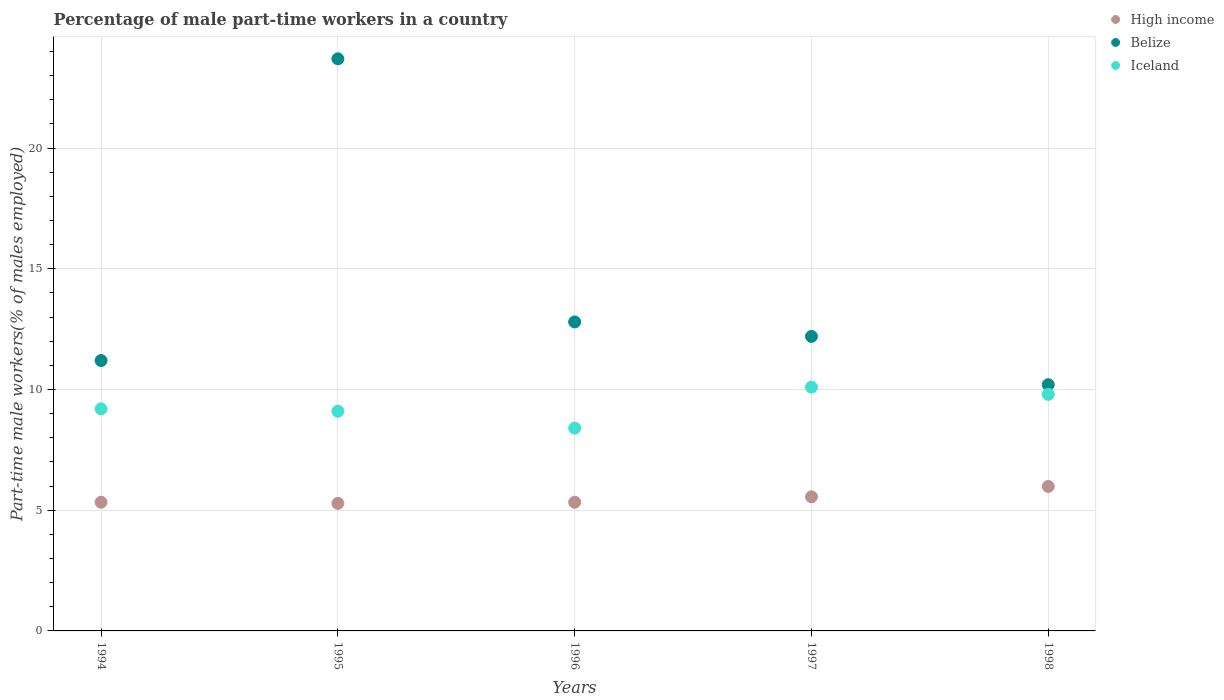What is the percentage of male part-time workers in Belize in 1994?
Keep it short and to the point. 11.2. Across all years, what is the maximum percentage of male part-time workers in Belize?
Provide a short and direct response. 23.7. Across all years, what is the minimum percentage of male part-time workers in High income?
Keep it short and to the point. 5.28. In which year was the percentage of male part-time workers in Iceland maximum?
Offer a very short reply. 1997. In which year was the percentage of male part-time workers in Belize minimum?
Ensure brevity in your answer.  1998. What is the total percentage of male part-time workers in Belize in the graph?
Make the answer very short. 70.1. What is the difference between the percentage of male part-time workers in Iceland in 1997 and that in 1998?
Keep it short and to the point. 0.3. What is the difference between the percentage of male part-time workers in High income in 1998 and the percentage of male part-time workers in Iceland in 1994?
Offer a very short reply. -3.22. What is the average percentage of male part-time workers in Iceland per year?
Offer a very short reply. 9.32. In the year 1996, what is the difference between the percentage of male part-time workers in Iceland and percentage of male part-time workers in High income?
Offer a terse response. 3.07. In how many years, is the percentage of male part-time workers in Belize greater than 21 %?
Offer a terse response. 1. What is the ratio of the percentage of male part-time workers in Belize in 1997 to that in 1998?
Offer a very short reply. 1.2. Is the percentage of male part-time workers in Iceland in 1994 less than that in 1996?
Give a very brief answer. No. What is the difference between the highest and the second highest percentage of male part-time workers in Belize?
Provide a succinct answer. 10.9. What is the difference between the highest and the lowest percentage of male part-time workers in Iceland?
Offer a terse response. 1.7. In how many years, is the percentage of male part-time workers in High income greater than the average percentage of male part-time workers in High income taken over all years?
Keep it short and to the point. 2. Is the sum of the percentage of male part-time workers in High income in 1994 and 1995 greater than the maximum percentage of male part-time workers in Belize across all years?
Provide a succinct answer. No. How many dotlines are there?
Make the answer very short. 3. How many years are there in the graph?
Offer a very short reply. 5. Does the graph contain grids?
Provide a short and direct response. Yes. Where does the legend appear in the graph?
Ensure brevity in your answer.  Top right. How many legend labels are there?
Offer a very short reply. 3. How are the legend labels stacked?
Make the answer very short. Vertical. What is the title of the graph?
Your response must be concise. Percentage of male part-time workers in a country. What is the label or title of the Y-axis?
Provide a short and direct response. Part-time male workers(% of males employed). What is the Part-time male workers(% of males employed) of High income in 1994?
Offer a terse response. 5.33. What is the Part-time male workers(% of males employed) in Belize in 1994?
Offer a terse response. 11.2. What is the Part-time male workers(% of males employed) of Iceland in 1994?
Ensure brevity in your answer.  9.2. What is the Part-time male workers(% of males employed) of High income in 1995?
Your answer should be compact. 5.28. What is the Part-time male workers(% of males employed) in Belize in 1995?
Keep it short and to the point. 23.7. What is the Part-time male workers(% of males employed) of Iceland in 1995?
Your answer should be compact. 9.1. What is the Part-time male workers(% of males employed) in High income in 1996?
Provide a succinct answer. 5.33. What is the Part-time male workers(% of males employed) in Belize in 1996?
Your response must be concise. 12.8. What is the Part-time male workers(% of males employed) of Iceland in 1996?
Your response must be concise. 8.4. What is the Part-time male workers(% of males employed) of High income in 1997?
Offer a very short reply. 5.56. What is the Part-time male workers(% of males employed) of Belize in 1997?
Your answer should be very brief. 12.2. What is the Part-time male workers(% of males employed) in Iceland in 1997?
Provide a succinct answer. 10.1. What is the Part-time male workers(% of males employed) of High income in 1998?
Provide a succinct answer. 5.98. What is the Part-time male workers(% of males employed) in Belize in 1998?
Your answer should be very brief. 10.2. What is the Part-time male workers(% of males employed) of Iceland in 1998?
Your response must be concise. 9.8. Across all years, what is the maximum Part-time male workers(% of males employed) of High income?
Give a very brief answer. 5.98. Across all years, what is the maximum Part-time male workers(% of males employed) in Belize?
Provide a short and direct response. 23.7. Across all years, what is the maximum Part-time male workers(% of males employed) in Iceland?
Your answer should be compact. 10.1. Across all years, what is the minimum Part-time male workers(% of males employed) of High income?
Ensure brevity in your answer.  5.28. Across all years, what is the minimum Part-time male workers(% of males employed) in Belize?
Your answer should be very brief. 10.2. Across all years, what is the minimum Part-time male workers(% of males employed) in Iceland?
Provide a short and direct response. 8.4. What is the total Part-time male workers(% of males employed) of High income in the graph?
Offer a very short reply. 27.49. What is the total Part-time male workers(% of males employed) of Belize in the graph?
Make the answer very short. 70.1. What is the total Part-time male workers(% of males employed) of Iceland in the graph?
Provide a short and direct response. 46.6. What is the difference between the Part-time male workers(% of males employed) of High income in 1994 and that in 1995?
Ensure brevity in your answer.  0.05. What is the difference between the Part-time male workers(% of males employed) in High income in 1994 and that in 1996?
Ensure brevity in your answer.  0. What is the difference between the Part-time male workers(% of males employed) of Belize in 1994 and that in 1996?
Your response must be concise. -1.6. What is the difference between the Part-time male workers(% of males employed) of Iceland in 1994 and that in 1996?
Keep it short and to the point. 0.8. What is the difference between the Part-time male workers(% of males employed) of High income in 1994 and that in 1997?
Your response must be concise. -0.22. What is the difference between the Part-time male workers(% of males employed) of Iceland in 1994 and that in 1997?
Your answer should be very brief. -0.9. What is the difference between the Part-time male workers(% of males employed) of High income in 1994 and that in 1998?
Offer a terse response. -0.65. What is the difference between the Part-time male workers(% of males employed) in Belize in 1994 and that in 1998?
Ensure brevity in your answer.  1. What is the difference between the Part-time male workers(% of males employed) of High income in 1995 and that in 1996?
Provide a succinct answer. -0.05. What is the difference between the Part-time male workers(% of males employed) of Belize in 1995 and that in 1996?
Provide a succinct answer. 10.9. What is the difference between the Part-time male workers(% of males employed) in Iceland in 1995 and that in 1996?
Offer a very short reply. 0.7. What is the difference between the Part-time male workers(% of males employed) in High income in 1995 and that in 1997?
Offer a terse response. -0.27. What is the difference between the Part-time male workers(% of males employed) in Belize in 1995 and that in 1997?
Your response must be concise. 11.5. What is the difference between the Part-time male workers(% of males employed) in High income in 1995 and that in 1998?
Keep it short and to the point. -0.7. What is the difference between the Part-time male workers(% of males employed) in High income in 1996 and that in 1997?
Offer a very short reply. -0.22. What is the difference between the Part-time male workers(% of males employed) of Belize in 1996 and that in 1997?
Offer a terse response. 0.6. What is the difference between the Part-time male workers(% of males employed) in Iceland in 1996 and that in 1997?
Give a very brief answer. -1.7. What is the difference between the Part-time male workers(% of males employed) of High income in 1996 and that in 1998?
Give a very brief answer. -0.65. What is the difference between the Part-time male workers(% of males employed) in High income in 1997 and that in 1998?
Your answer should be compact. -0.43. What is the difference between the Part-time male workers(% of males employed) in Belize in 1997 and that in 1998?
Your answer should be compact. 2. What is the difference between the Part-time male workers(% of males employed) of Iceland in 1997 and that in 1998?
Your answer should be compact. 0.3. What is the difference between the Part-time male workers(% of males employed) in High income in 1994 and the Part-time male workers(% of males employed) in Belize in 1995?
Keep it short and to the point. -18.37. What is the difference between the Part-time male workers(% of males employed) of High income in 1994 and the Part-time male workers(% of males employed) of Iceland in 1995?
Offer a terse response. -3.77. What is the difference between the Part-time male workers(% of males employed) in Belize in 1994 and the Part-time male workers(% of males employed) in Iceland in 1995?
Ensure brevity in your answer.  2.1. What is the difference between the Part-time male workers(% of males employed) in High income in 1994 and the Part-time male workers(% of males employed) in Belize in 1996?
Your answer should be very brief. -7.47. What is the difference between the Part-time male workers(% of males employed) of High income in 1994 and the Part-time male workers(% of males employed) of Iceland in 1996?
Offer a terse response. -3.07. What is the difference between the Part-time male workers(% of males employed) in High income in 1994 and the Part-time male workers(% of males employed) in Belize in 1997?
Provide a short and direct response. -6.87. What is the difference between the Part-time male workers(% of males employed) in High income in 1994 and the Part-time male workers(% of males employed) in Iceland in 1997?
Provide a short and direct response. -4.77. What is the difference between the Part-time male workers(% of males employed) of High income in 1994 and the Part-time male workers(% of males employed) of Belize in 1998?
Your answer should be compact. -4.87. What is the difference between the Part-time male workers(% of males employed) in High income in 1994 and the Part-time male workers(% of males employed) in Iceland in 1998?
Offer a very short reply. -4.47. What is the difference between the Part-time male workers(% of males employed) of Belize in 1994 and the Part-time male workers(% of males employed) of Iceland in 1998?
Offer a terse response. 1.4. What is the difference between the Part-time male workers(% of males employed) of High income in 1995 and the Part-time male workers(% of males employed) of Belize in 1996?
Keep it short and to the point. -7.52. What is the difference between the Part-time male workers(% of males employed) in High income in 1995 and the Part-time male workers(% of males employed) in Iceland in 1996?
Your answer should be very brief. -3.12. What is the difference between the Part-time male workers(% of males employed) of Belize in 1995 and the Part-time male workers(% of males employed) of Iceland in 1996?
Give a very brief answer. 15.3. What is the difference between the Part-time male workers(% of males employed) in High income in 1995 and the Part-time male workers(% of males employed) in Belize in 1997?
Provide a short and direct response. -6.92. What is the difference between the Part-time male workers(% of males employed) of High income in 1995 and the Part-time male workers(% of males employed) of Iceland in 1997?
Provide a succinct answer. -4.82. What is the difference between the Part-time male workers(% of males employed) of High income in 1995 and the Part-time male workers(% of males employed) of Belize in 1998?
Keep it short and to the point. -4.92. What is the difference between the Part-time male workers(% of males employed) in High income in 1995 and the Part-time male workers(% of males employed) in Iceland in 1998?
Your answer should be very brief. -4.52. What is the difference between the Part-time male workers(% of males employed) of High income in 1996 and the Part-time male workers(% of males employed) of Belize in 1997?
Your answer should be very brief. -6.87. What is the difference between the Part-time male workers(% of males employed) of High income in 1996 and the Part-time male workers(% of males employed) of Iceland in 1997?
Offer a terse response. -4.77. What is the difference between the Part-time male workers(% of males employed) in Belize in 1996 and the Part-time male workers(% of males employed) in Iceland in 1997?
Your answer should be very brief. 2.7. What is the difference between the Part-time male workers(% of males employed) in High income in 1996 and the Part-time male workers(% of males employed) in Belize in 1998?
Your answer should be very brief. -4.87. What is the difference between the Part-time male workers(% of males employed) of High income in 1996 and the Part-time male workers(% of males employed) of Iceland in 1998?
Provide a succinct answer. -4.47. What is the difference between the Part-time male workers(% of males employed) in Belize in 1996 and the Part-time male workers(% of males employed) in Iceland in 1998?
Ensure brevity in your answer.  3. What is the difference between the Part-time male workers(% of males employed) in High income in 1997 and the Part-time male workers(% of males employed) in Belize in 1998?
Your answer should be compact. -4.64. What is the difference between the Part-time male workers(% of males employed) of High income in 1997 and the Part-time male workers(% of males employed) of Iceland in 1998?
Make the answer very short. -4.24. What is the average Part-time male workers(% of males employed) of High income per year?
Your answer should be very brief. 5.5. What is the average Part-time male workers(% of males employed) in Belize per year?
Provide a succinct answer. 14.02. What is the average Part-time male workers(% of males employed) of Iceland per year?
Ensure brevity in your answer.  9.32. In the year 1994, what is the difference between the Part-time male workers(% of males employed) of High income and Part-time male workers(% of males employed) of Belize?
Keep it short and to the point. -5.87. In the year 1994, what is the difference between the Part-time male workers(% of males employed) in High income and Part-time male workers(% of males employed) in Iceland?
Provide a short and direct response. -3.87. In the year 1995, what is the difference between the Part-time male workers(% of males employed) in High income and Part-time male workers(% of males employed) in Belize?
Your answer should be very brief. -18.42. In the year 1995, what is the difference between the Part-time male workers(% of males employed) of High income and Part-time male workers(% of males employed) of Iceland?
Offer a terse response. -3.82. In the year 1996, what is the difference between the Part-time male workers(% of males employed) in High income and Part-time male workers(% of males employed) in Belize?
Provide a short and direct response. -7.47. In the year 1996, what is the difference between the Part-time male workers(% of males employed) of High income and Part-time male workers(% of males employed) of Iceland?
Offer a very short reply. -3.07. In the year 1996, what is the difference between the Part-time male workers(% of males employed) in Belize and Part-time male workers(% of males employed) in Iceland?
Provide a short and direct response. 4.4. In the year 1997, what is the difference between the Part-time male workers(% of males employed) of High income and Part-time male workers(% of males employed) of Belize?
Your answer should be very brief. -6.64. In the year 1997, what is the difference between the Part-time male workers(% of males employed) of High income and Part-time male workers(% of males employed) of Iceland?
Provide a short and direct response. -4.54. In the year 1998, what is the difference between the Part-time male workers(% of males employed) of High income and Part-time male workers(% of males employed) of Belize?
Keep it short and to the point. -4.22. In the year 1998, what is the difference between the Part-time male workers(% of males employed) in High income and Part-time male workers(% of males employed) in Iceland?
Give a very brief answer. -3.82. In the year 1998, what is the difference between the Part-time male workers(% of males employed) in Belize and Part-time male workers(% of males employed) in Iceland?
Offer a very short reply. 0.4. What is the ratio of the Part-time male workers(% of males employed) of High income in 1994 to that in 1995?
Your answer should be compact. 1.01. What is the ratio of the Part-time male workers(% of males employed) in Belize in 1994 to that in 1995?
Provide a succinct answer. 0.47. What is the ratio of the Part-time male workers(% of males employed) in Belize in 1994 to that in 1996?
Offer a terse response. 0.88. What is the ratio of the Part-time male workers(% of males employed) in Iceland in 1994 to that in 1996?
Provide a succinct answer. 1.1. What is the ratio of the Part-time male workers(% of males employed) in High income in 1994 to that in 1997?
Provide a short and direct response. 0.96. What is the ratio of the Part-time male workers(% of males employed) in Belize in 1994 to that in 1997?
Your answer should be compact. 0.92. What is the ratio of the Part-time male workers(% of males employed) in Iceland in 1994 to that in 1997?
Provide a short and direct response. 0.91. What is the ratio of the Part-time male workers(% of males employed) of High income in 1994 to that in 1998?
Your response must be concise. 0.89. What is the ratio of the Part-time male workers(% of males employed) of Belize in 1994 to that in 1998?
Your answer should be very brief. 1.1. What is the ratio of the Part-time male workers(% of males employed) of Iceland in 1994 to that in 1998?
Offer a very short reply. 0.94. What is the ratio of the Part-time male workers(% of males employed) in Belize in 1995 to that in 1996?
Provide a short and direct response. 1.85. What is the ratio of the Part-time male workers(% of males employed) of Iceland in 1995 to that in 1996?
Your answer should be very brief. 1.08. What is the ratio of the Part-time male workers(% of males employed) of High income in 1995 to that in 1997?
Your answer should be very brief. 0.95. What is the ratio of the Part-time male workers(% of males employed) of Belize in 1995 to that in 1997?
Your answer should be very brief. 1.94. What is the ratio of the Part-time male workers(% of males employed) of Iceland in 1995 to that in 1997?
Make the answer very short. 0.9. What is the ratio of the Part-time male workers(% of males employed) of High income in 1995 to that in 1998?
Provide a succinct answer. 0.88. What is the ratio of the Part-time male workers(% of males employed) in Belize in 1995 to that in 1998?
Offer a terse response. 2.32. What is the ratio of the Part-time male workers(% of males employed) of High income in 1996 to that in 1997?
Provide a short and direct response. 0.96. What is the ratio of the Part-time male workers(% of males employed) of Belize in 1996 to that in 1997?
Your answer should be very brief. 1.05. What is the ratio of the Part-time male workers(% of males employed) of Iceland in 1996 to that in 1997?
Give a very brief answer. 0.83. What is the ratio of the Part-time male workers(% of males employed) of High income in 1996 to that in 1998?
Make the answer very short. 0.89. What is the ratio of the Part-time male workers(% of males employed) of Belize in 1996 to that in 1998?
Ensure brevity in your answer.  1.25. What is the ratio of the Part-time male workers(% of males employed) of Iceland in 1996 to that in 1998?
Provide a succinct answer. 0.86. What is the ratio of the Part-time male workers(% of males employed) in High income in 1997 to that in 1998?
Your answer should be compact. 0.93. What is the ratio of the Part-time male workers(% of males employed) in Belize in 1997 to that in 1998?
Keep it short and to the point. 1.2. What is the ratio of the Part-time male workers(% of males employed) of Iceland in 1997 to that in 1998?
Your response must be concise. 1.03. What is the difference between the highest and the second highest Part-time male workers(% of males employed) in High income?
Your answer should be very brief. 0.43. What is the difference between the highest and the second highest Part-time male workers(% of males employed) of Belize?
Provide a succinct answer. 10.9. What is the difference between the highest and the second highest Part-time male workers(% of males employed) in Iceland?
Make the answer very short. 0.3. What is the difference between the highest and the lowest Part-time male workers(% of males employed) of High income?
Provide a succinct answer. 0.7. What is the difference between the highest and the lowest Part-time male workers(% of males employed) of Iceland?
Your answer should be compact. 1.7. 